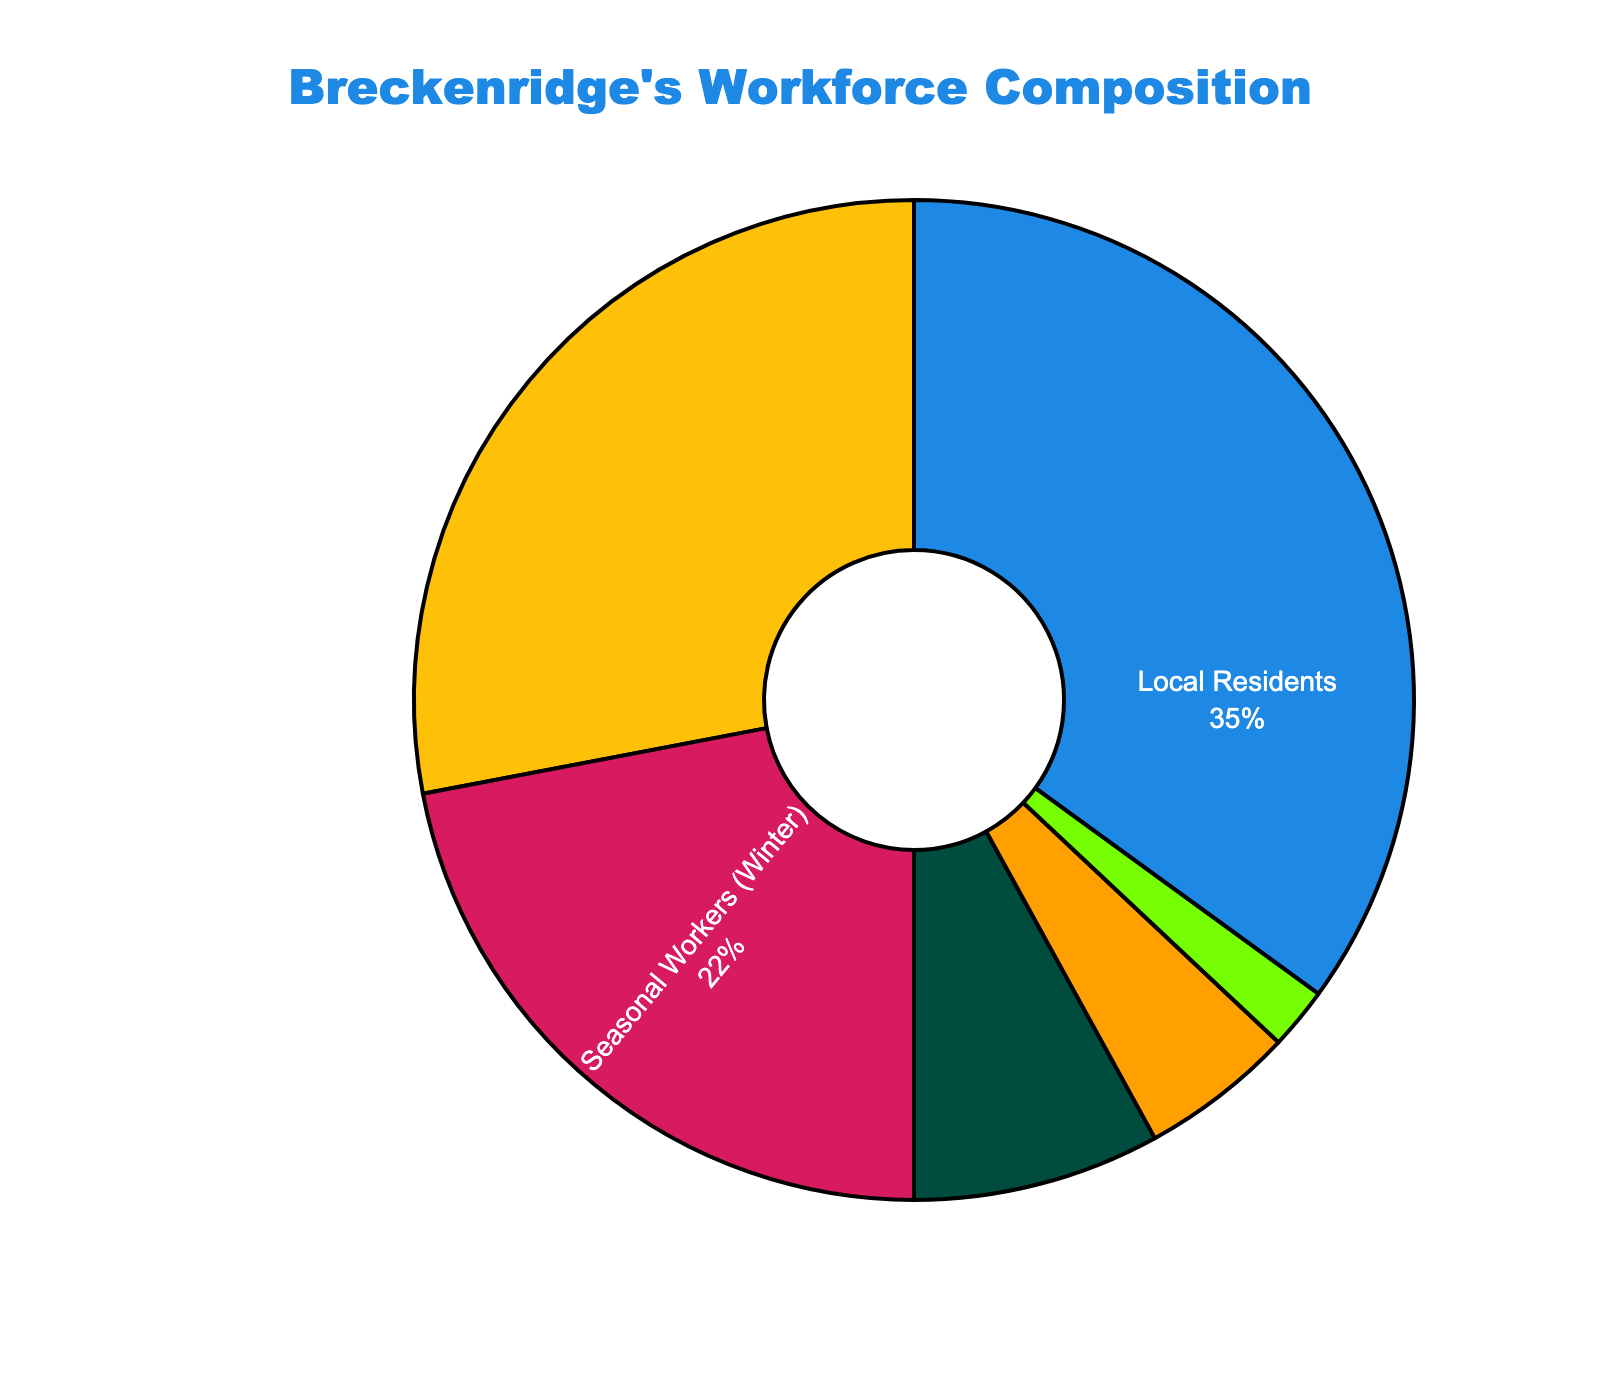What percentage of Breckenridge's workforce are non-local residents? To find the percentage of non-local residents, sum the percentages of Daily Commuters from Summit County, Seasonal Workers (Winter), Seasonal Workers (Summer), Long-distance Commuters, and Remote Workers. This calculation is 28% + 22% + 8% + 5% + 2% = 65%.
Answer: 65% Which group represents the largest portion of Breckenridge's workforce? The pie chart shows different segments with their respective percentages. The largest portion is represented by Local Residents with 35%.
Answer: Local Residents Are there more Daily Commuters from Summit County or Seasonal Workers (Winter)? Compare the percentages of Daily Commuters from Summit County (28%) and Seasonal Workers (Winter) (22%). 28% is greater than 22%.
Answer: Daily Commuters from Summit County What is the combined percentage of Seasonal Workers in both winter and summer? Add the percentages of Seasonal Workers (Winter) and Seasonal Workers (Summer). The total is 22% + 8% = 30%.
Answer: 30% Is the percentage of Remote Workers greater than that of Long-distance Commuters? Compare the percentages of Remote Workers (2%) and Long-distance Commuters (5%). 2% is less than 5%.
Answer: No What is the difference in workforce percentage between Local Residents and Daily Commuters from Summit County? Subtract the percentage of Daily Commuters from Summit County (28%) from Local Residents (35%). The difference is 35% - 28% = 7%.
Answer: 7% How does the percentage of Seasonal Workers (Summer) compare to Remote Workers? Compare the percentages of Seasonal Workers (Summer) (8%) and Remote Workers (2%). 8% is greater than 2%.
Answer: Seasonal Workers (Summer) are more What proportion of the workforce do Long-distance Commuters and Remote Workers together constitute? Add the percentages of Long-distance Commuters and Remote Workers. The total is 5% + 2% = 7%.
Answer: 7% What is the percentage share of Seasonal Workers (Winter) compared to the total non-local workforce? The total non-local workforce is 65%. The share of Seasonal Workers (Winter) within this total is calculated as (22% / 65%) * 100 ≈ 33.85%.
Answer: ~34% Considering only the commuting categories, which group has the smaller percentage: Daily Commuters from Summit County or Long-distance Commuters? Compare the percentages of Daily Commuters from Summit County (28%) and Long-distance Commuters (5%). 5% is smaller than 28%.
Answer: Long-distance Commuters 